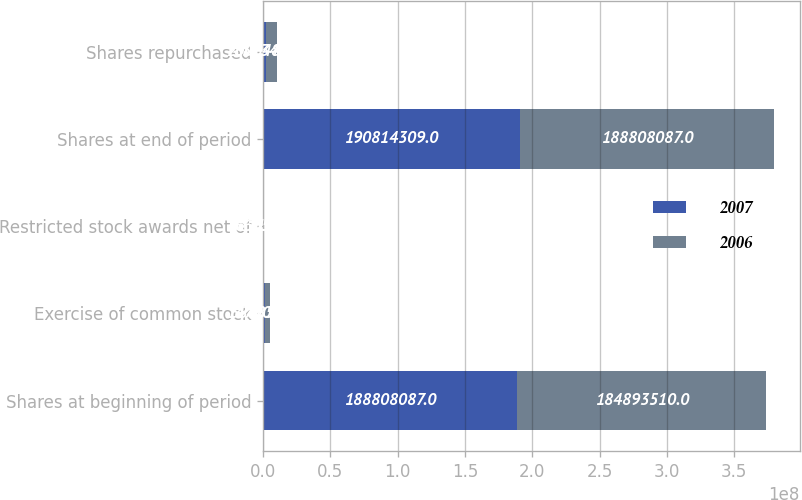<chart> <loc_0><loc_0><loc_500><loc_500><stacked_bar_chart><ecel><fcel>Shares at beginning of period<fcel>Exercise of common stock<fcel>Restricted stock awards net of<fcel>Shares at end of period<fcel>Shares repurchased<nl><fcel>2007<fcel>1.88808e+08<fcel>1.47904e+06<fcel>527182<fcel>1.90814e+08<fcel>2.00648e+06<nl><fcel>2006<fcel>1.84894e+08<fcel>3.84852e+06<fcel>66056<fcel>1.88808e+08<fcel>8.3734e+06<nl></chart> 